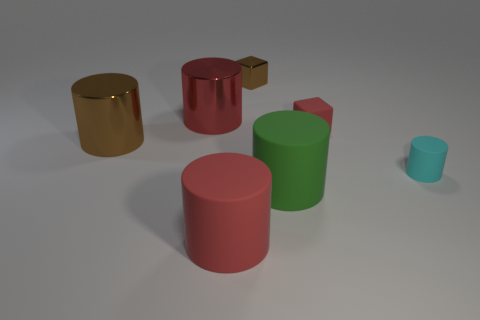There is another metal object that is the same color as the tiny shiny object; what is its shape?
Provide a succinct answer. Cylinder. There is a tiny shiny block; does it have the same color as the large shiny cylinder in front of the small red thing?
Make the answer very short. Yes. What size is the metallic thing that is the same color as the rubber cube?
Give a very brief answer. Large. Are there any metallic cylinders of the same color as the rubber block?
Your answer should be compact. Yes. What size is the red thing that is behind the cyan matte thing and left of the green matte thing?
Your answer should be very brief. Large. Is there a large thing made of the same material as the tiny red object?
Your answer should be very brief. Yes. The cyan thing has what shape?
Your response must be concise. Cylinder. Do the brown metal cube and the brown cylinder have the same size?
Offer a very short reply. No. How many other objects are the same shape as the large brown object?
Ensure brevity in your answer.  4. What is the shape of the big matte object left of the brown block?
Ensure brevity in your answer.  Cylinder. 